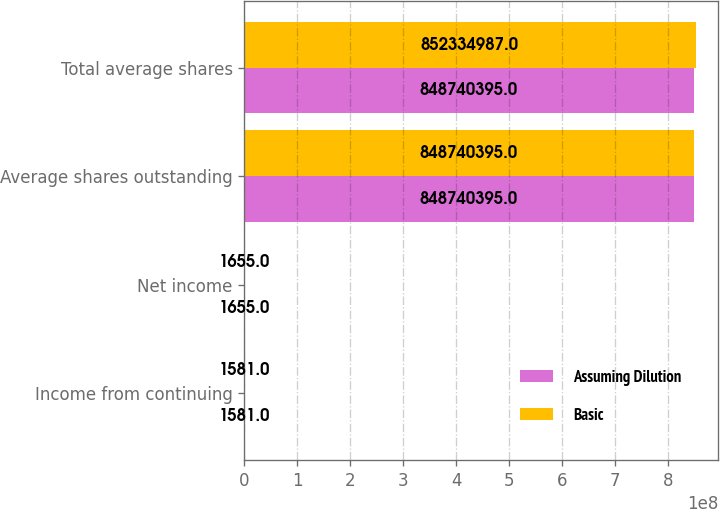Convert chart to OTSL. <chart><loc_0><loc_0><loc_500><loc_500><stacked_bar_chart><ecel><fcel>Income from continuing<fcel>Net income<fcel>Average shares outstanding<fcel>Total average shares<nl><fcel>Assuming Dilution<fcel>1581<fcel>1655<fcel>8.4874e+08<fcel>8.4874e+08<nl><fcel>Basic<fcel>1581<fcel>1655<fcel>8.4874e+08<fcel>8.52335e+08<nl></chart> 